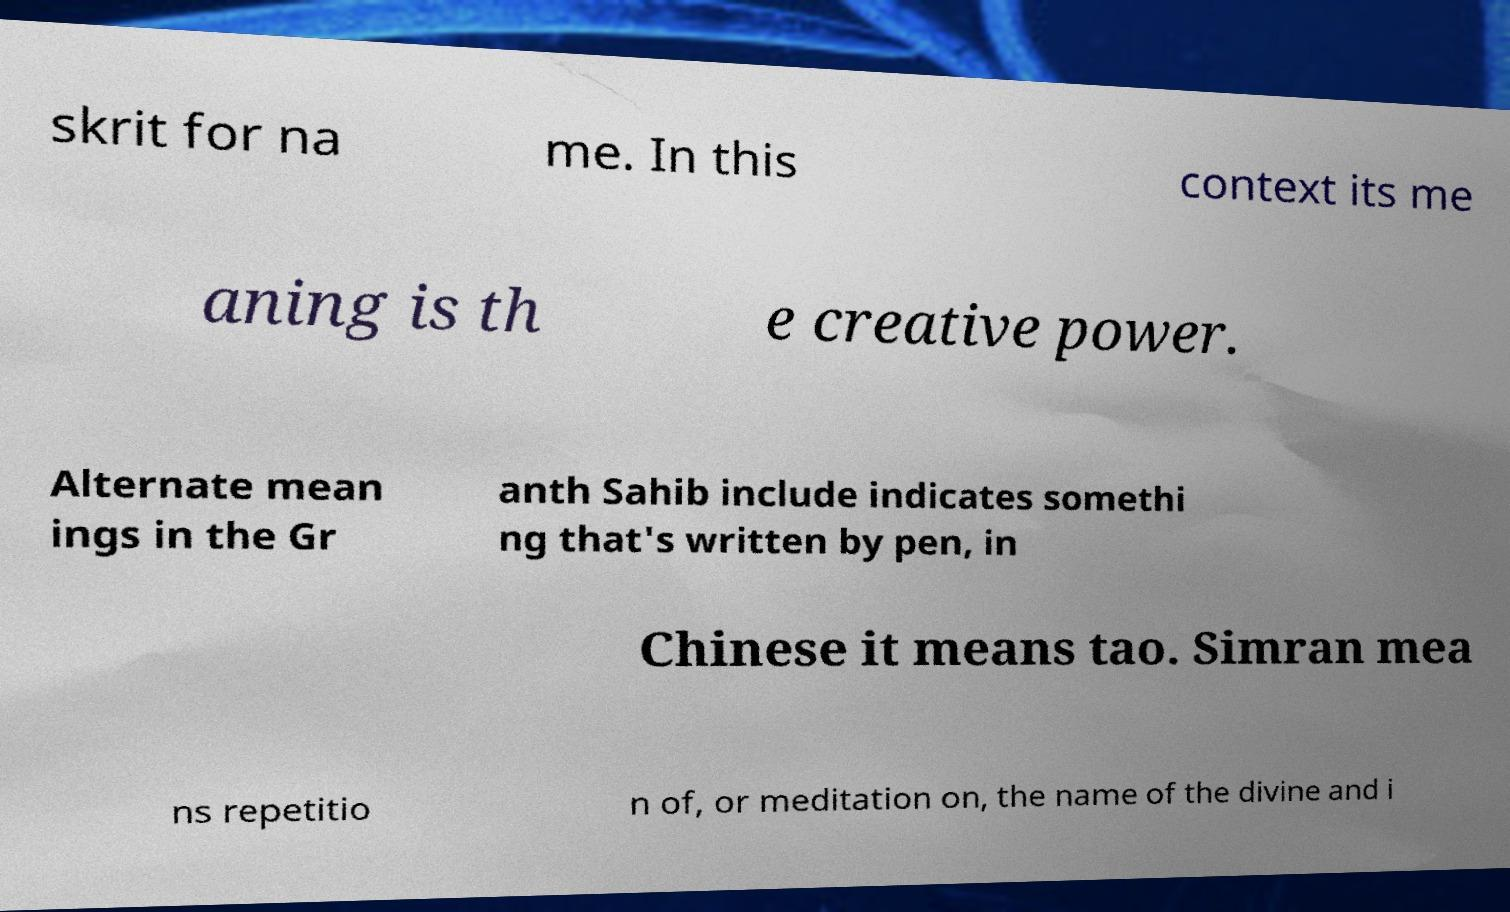Please identify and transcribe the text found in this image. skrit for na me. In this context its me aning is th e creative power. Alternate mean ings in the Gr anth Sahib include indicates somethi ng that's written by pen, in Chinese it means tao. Simran mea ns repetitio n of, or meditation on, the name of the divine and i 